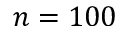<formula> <loc_0><loc_0><loc_500><loc_500>n = 1 0 0</formula> 